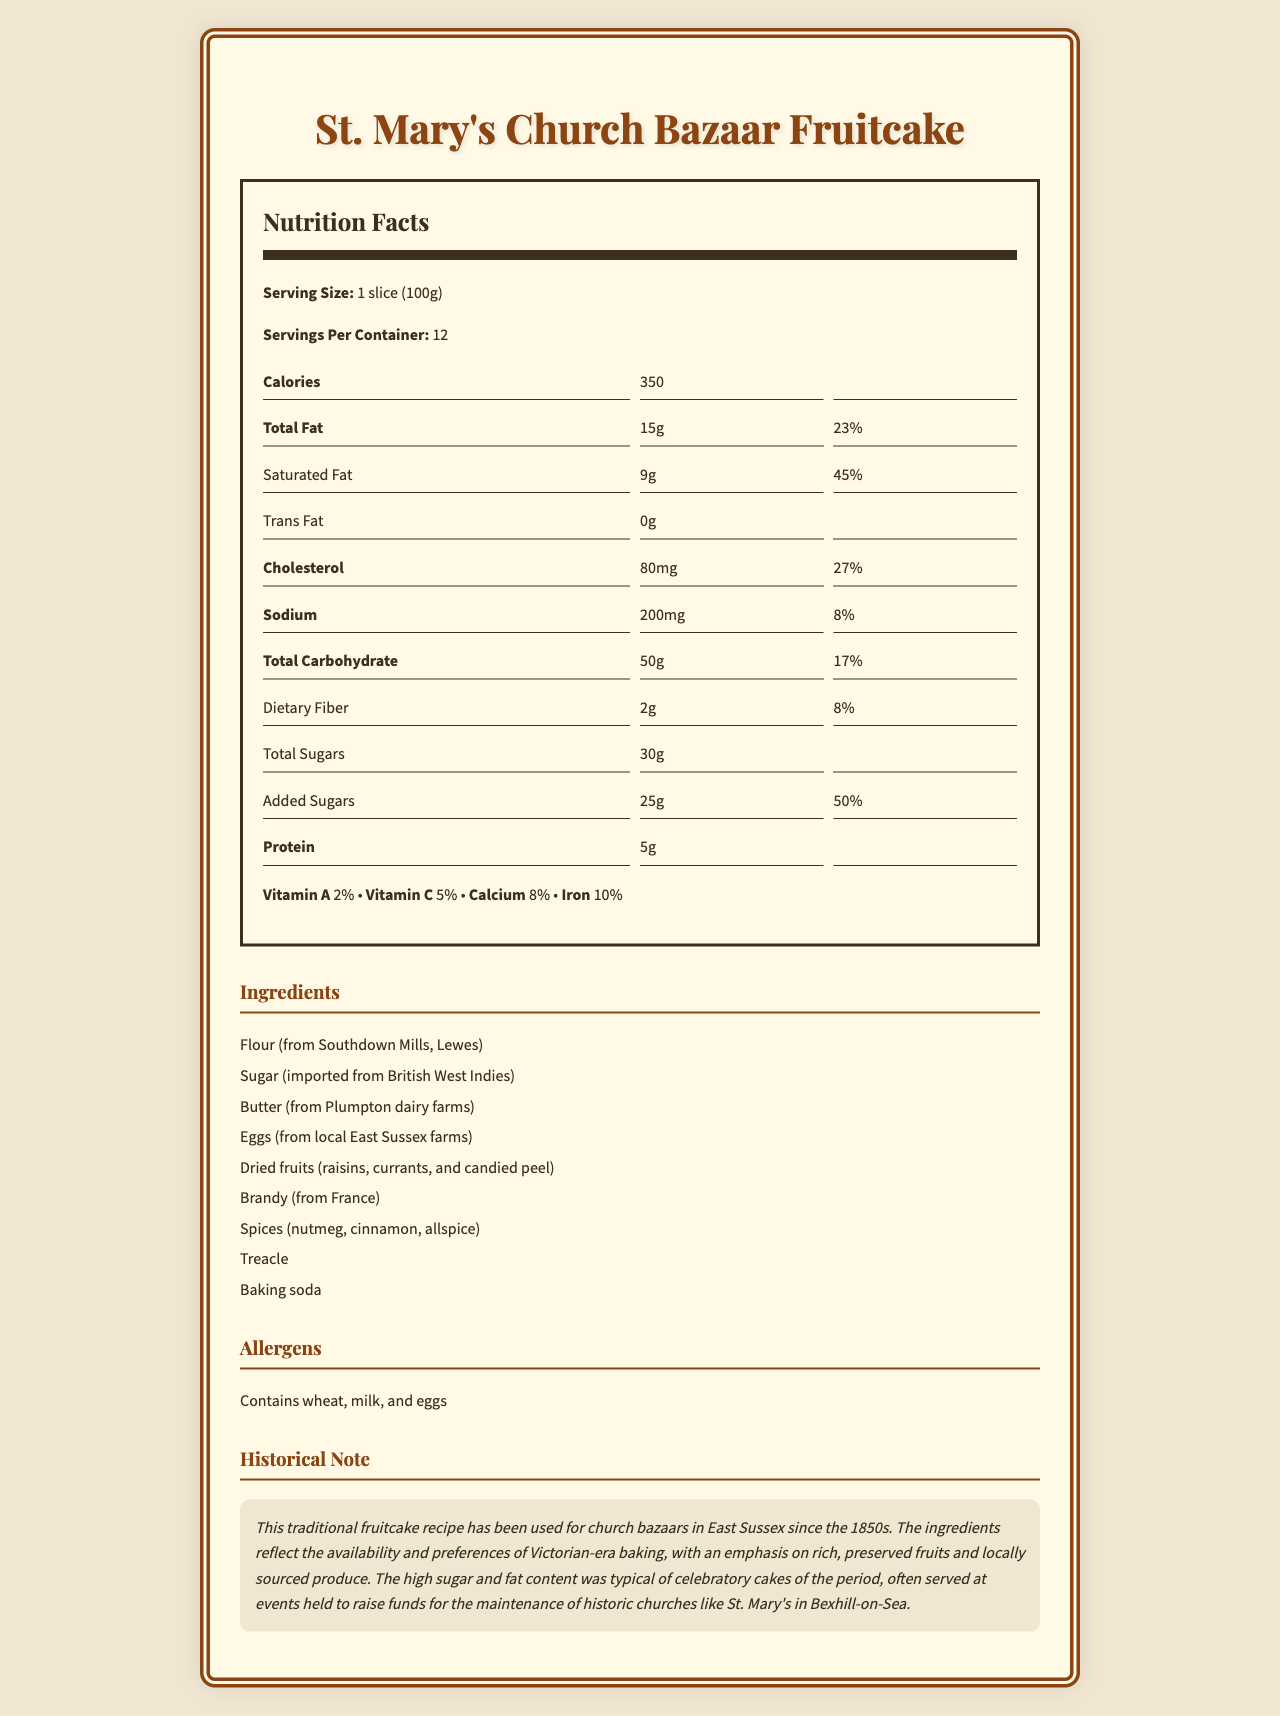what is the serving size? The serving size is clearly mentioned in the nutrition label under the nutrition facts section.
Answer: 1 slice (100g) how many calories are there per serving? The document states that each serving size of the cake has 350 calories.
Answer: 350 how many servings are there per container? The servings per container are mentioned as 12 in the nutrition facts section.
Answer: 12 how much total fat is in one serving? The total fat content is written as 15g per serving in the nutrition label.
Answer: 15g what is the percentage of daily value for saturated fat in one serving? The daily value percentage for saturated fat is listed as 45% on the nutrition facts label.
Answer: 45% which historical ingredients are mentioned in the cake? A. Flour and eggs B. Sugar and butter C. Raisins and brandy D. All of the above The ingredients list includes flour, sugar, butter, eggs, raisins, and brandy, so the correct answer is all of the above.
Answer: D. All of the above where is the butter sourced from? A. Southdown Mills B. Local East Sussex farms C. Plumpton dairy farms D. British West Indies The ingredients section indicates that the butter is sourced from Plumpton dairy farms.
Answer: C. Plumpton dairy farms does the cake contain eggs as allergens? The document lists eggs as one of the allergens in the cake.
Answer: Yes what percentages of daily value do calcium and iron contribute per serving? The nutrition facts section provides the daily value percentages for these vitamins: calcium at 8% and iron at 10%.
Answer: Calcium: 8%, Iron: 10% how are the vitamins listed in the nutrition label? The nutrition facts label lists the vitamins in the order of Vitamin A, Vitamin C, Calcium, and Iron.
Answer: Vitamin A, Vitamin C, Calcium, Iron which local mills provided the flour for this recipe? The ingredients section states that the flour is from Southdown Mills, Lewes.
Answer: Southdown Mills, Lewes why was the high sugar and fat content typical for celebratory cakes of the Victorian era? The historical note explains that high sugar and fat content were typical because it provided richness and facilitated the preservation of the cake.
Answer: Richness and preservation summarize the document. The document includes nutrition facts, a list of ingredients (many sourced locally), allergen information, and a historical note on the Victorian-era significance of the cake's ingredients and their usage.
Answer: The document provides detailed nutrition facts and ingredients for St. Mary's Church Bazaar Fruitcake, emphasizing locally sourced Victorian-era ingredients. The cake is rich and preserved with high fat and sugar content, typical for celebratory cakes of the 1850s used in church bazaars to raise funds. what percent of the daily value of protein does one serving provide? The document does not provide the daily value percentage for protein, only the amount which is 5g.
Answer: Not available 